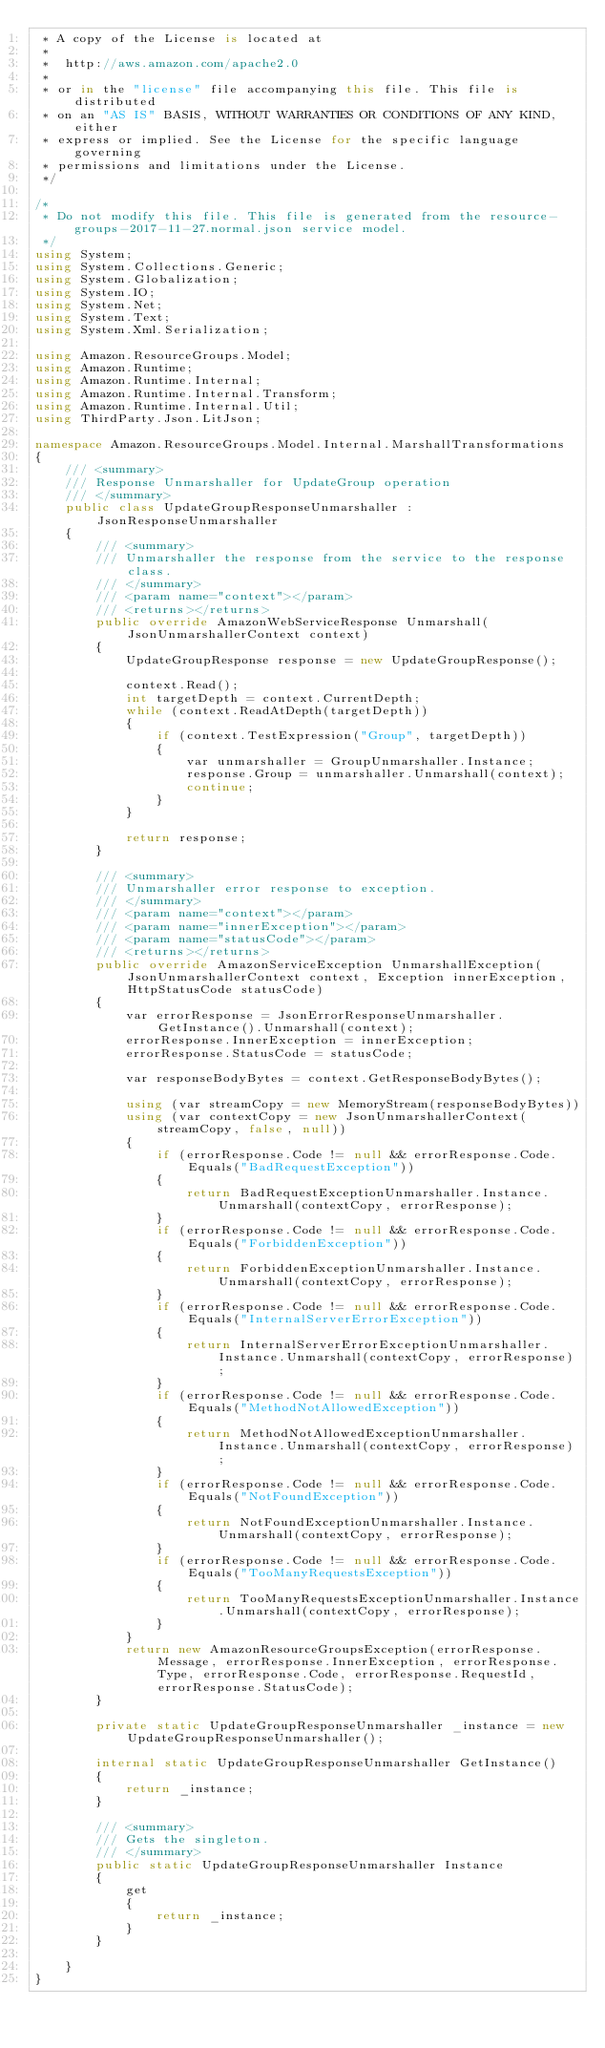<code> <loc_0><loc_0><loc_500><loc_500><_C#_> * A copy of the License is located at
 * 
 *  http://aws.amazon.com/apache2.0
 * 
 * or in the "license" file accompanying this file. This file is distributed
 * on an "AS IS" BASIS, WITHOUT WARRANTIES OR CONDITIONS OF ANY KIND, either
 * express or implied. See the License for the specific language governing
 * permissions and limitations under the License.
 */

/*
 * Do not modify this file. This file is generated from the resource-groups-2017-11-27.normal.json service model.
 */
using System;
using System.Collections.Generic;
using System.Globalization;
using System.IO;
using System.Net;
using System.Text;
using System.Xml.Serialization;

using Amazon.ResourceGroups.Model;
using Amazon.Runtime;
using Amazon.Runtime.Internal;
using Amazon.Runtime.Internal.Transform;
using Amazon.Runtime.Internal.Util;
using ThirdParty.Json.LitJson;

namespace Amazon.ResourceGroups.Model.Internal.MarshallTransformations
{
    /// <summary>
    /// Response Unmarshaller for UpdateGroup operation
    /// </summary>  
    public class UpdateGroupResponseUnmarshaller : JsonResponseUnmarshaller
    {
        /// <summary>
        /// Unmarshaller the response from the service to the response class.
        /// </summary>  
        /// <param name="context"></param>
        /// <returns></returns>
        public override AmazonWebServiceResponse Unmarshall(JsonUnmarshallerContext context)
        {
            UpdateGroupResponse response = new UpdateGroupResponse();

            context.Read();
            int targetDepth = context.CurrentDepth;
            while (context.ReadAtDepth(targetDepth))
            {
                if (context.TestExpression("Group", targetDepth))
                {
                    var unmarshaller = GroupUnmarshaller.Instance;
                    response.Group = unmarshaller.Unmarshall(context);
                    continue;
                }
            }

            return response;
        }

        /// <summary>
        /// Unmarshaller error response to exception.
        /// </summary>  
        /// <param name="context"></param>
        /// <param name="innerException"></param>
        /// <param name="statusCode"></param>
        /// <returns></returns>
        public override AmazonServiceException UnmarshallException(JsonUnmarshallerContext context, Exception innerException, HttpStatusCode statusCode)
        {
            var errorResponse = JsonErrorResponseUnmarshaller.GetInstance().Unmarshall(context);
            errorResponse.InnerException = innerException;
            errorResponse.StatusCode = statusCode;

            var responseBodyBytes = context.GetResponseBodyBytes();

            using (var streamCopy = new MemoryStream(responseBodyBytes))
            using (var contextCopy = new JsonUnmarshallerContext(streamCopy, false, null))
            {
                if (errorResponse.Code != null && errorResponse.Code.Equals("BadRequestException"))
                {
                    return BadRequestExceptionUnmarshaller.Instance.Unmarshall(contextCopy, errorResponse);
                }
                if (errorResponse.Code != null && errorResponse.Code.Equals("ForbiddenException"))
                {
                    return ForbiddenExceptionUnmarshaller.Instance.Unmarshall(contextCopy, errorResponse);
                }
                if (errorResponse.Code != null && errorResponse.Code.Equals("InternalServerErrorException"))
                {
                    return InternalServerErrorExceptionUnmarshaller.Instance.Unmarshall(contextCopy, errorResponse);
                }
                if (errorResponse.Code != null && errorResponse.Code.Equals("MethodNotAllowedException"))
                {
                    return MethodNotAllowedExceptionUnmarshaller.Instance.Unmarshall(contextCopy, errorResponse);
                }
                if (errorResponse.Code != null && errorResponse.Code.Equals("NotFoundException"))
                {
                    return NotFoundExceptionUnmarshaller.Instance.Unmarshall(contextCopy, errorResponse);
                }
                if (errorResponse.Code != null && errorResponse.Code.Equals("TooManyRequestsException"))
                {
                    return TooManyRequestsExceptionUnmarshaller.Instance.Unmarshall(contextCopy, errorResponse);
                }
            }
            return new AmazonResourceGroupsException(errorResponse.Message, errorResponse.InnerException, errorResponse.Type, errorResponse.Code, errorResponse.RequestId, errorResponse.StatusCode);
        }

        private static UpdateGroupResponseUnmarshaller _instance = new UpdateGroupResponseUnmarshaller();        

        internal static UpdateGroupResponseUnmarshaller GetInstance()
        {
            return _instance;
        }

        /// <summary>
        /// Gets the singleton.
        /// </summary>  
        public static UpdateGroupResponseUnmarshaller Instance
        {
            get
            {
                return _instance;
            }
        }

    }
}</code> 